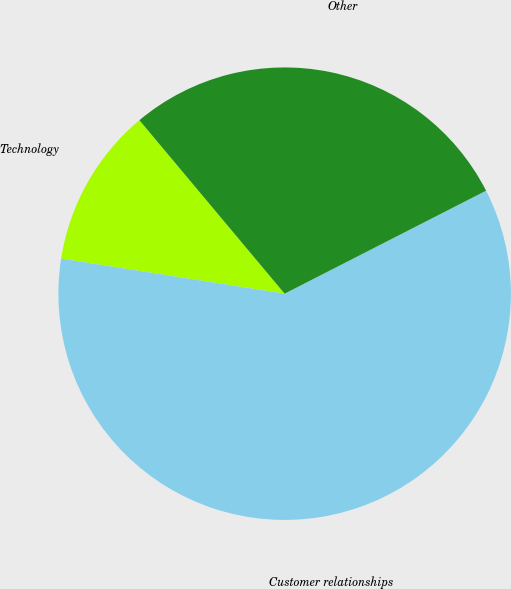Convert chart to OTSL. <chart><loc_0><loc_0><loc_500><loc_500><pie_chart><fcel>Technology<fcel>Customer relationships<fcel>Other<nl><fcel>11.43%<fcel>60.0%<fcel>28.57%<nl></chart> 